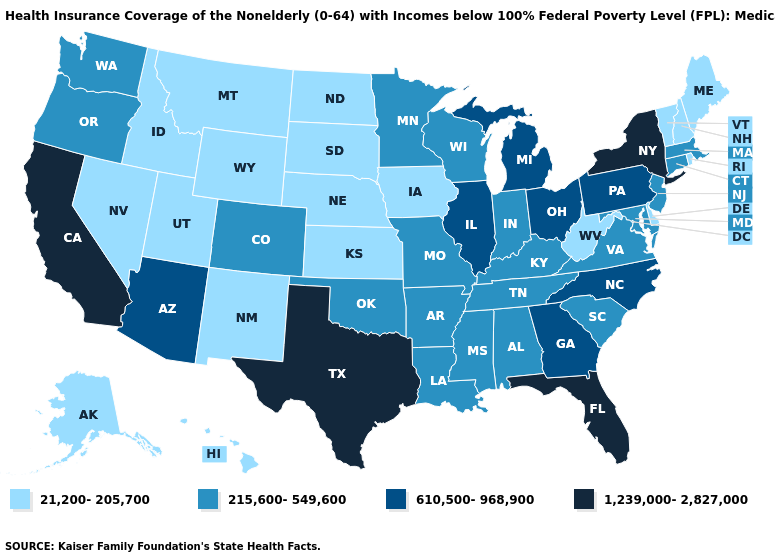What is the lowest value in states that border Massachusetts?
Be succinct. 21,200-205,700. What is the value of Massachusetts?
Concise answer only. 215,600-549,600. Does Iowa have the highest value in the MidWest?
Be succinct. No. What is the value of Maryland?
Quick response, please. 215,600-549,600. Does Indiana have the same value as Oregon?
Concise answer only. Yes. Does South Dakota have the lowest value in the MidWest?
Write a very short answer. Yes. Name the states that have a value in the range 610,500-968,900?
Quick response, please. Arizona, Georgia, Illinois, Michigan, North Carolina, Ohio, Pennsylvania. What is the lowest value in states that border Vermont?
Give a very brief answer. 21,200-205,700. What is the value of Mississippi?
Concise answer only. 215,600-549,600. Which states hav the highest value in the West?
Quick response, please. California. Name the states that have a value in the range 610,500-968,900?
Quick response, please. Arizona, Georgia, Illinois, Michigan, North Carolina, Ohio, Pennsylvania. Which states hav the highest value in the West?
Quick response, please. California. What is the lowest value in the USA?
Short answer required. 21,200-205,700. What is the value of Mississippi?
Give a very brief answer. 215,600-549,600. What is the highest value in the West ?
Write a very short answer. 1,239,000-2,827,000. 